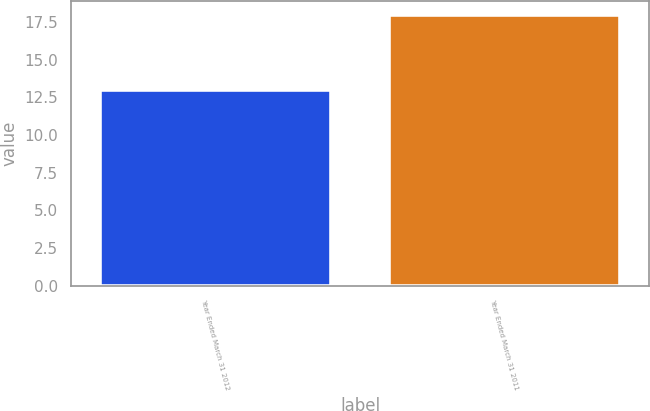Convert chart. <chart><loc_0><loc_0><loc_500><loc_500><bar_chart><fcel>Year Ended March 31 2012<fcel>Year Ended March 31 2011<nl><fcel>13<fcel>18<nl></chart> 